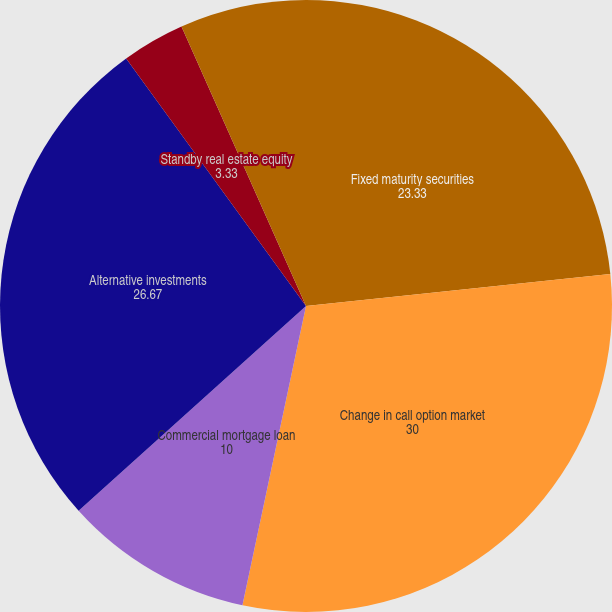<chart> <loc_0><loc_0><loc_500><loc_500><pie_chart><fcel>Fixed maturity securities<fcel>Change in call option market<fcel>Commercial mortgage loan<fcel>Alternative investments<fcel>Standby real estate equity<fcel>et investment income yield on<nl><fcel>23.33%<fcel>30.0%<fcel>10.0%<fcel>26.67%<fcel>3.33%<fcel>6.67%<nl></chart> 